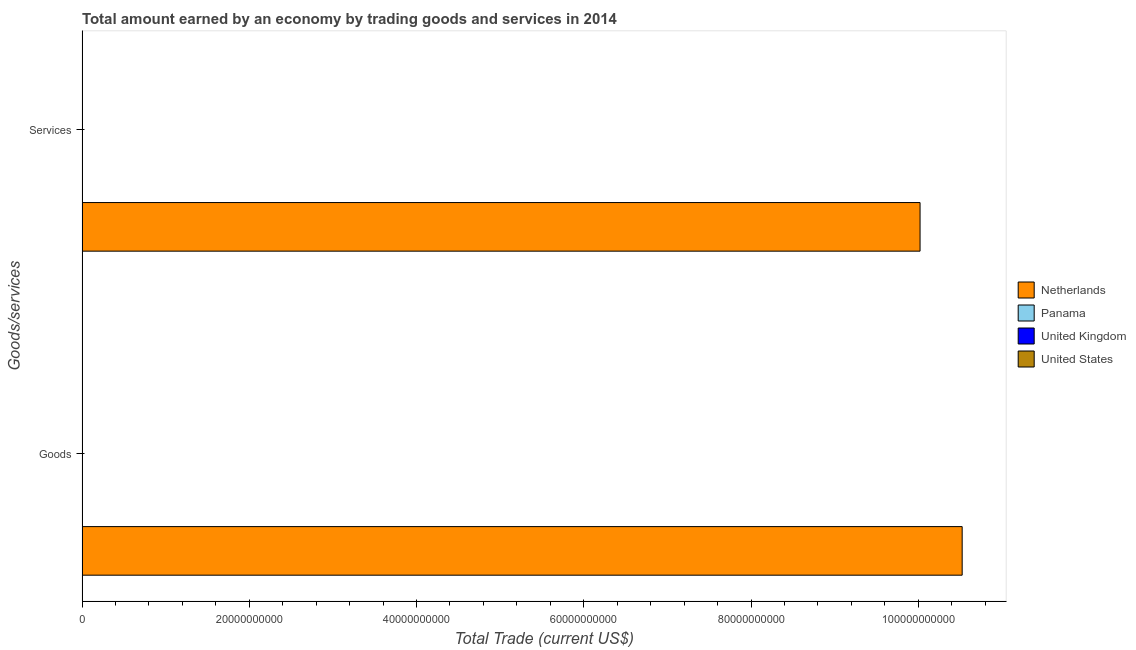How many different coloured bars are there?
Keep it short and to the point. 1. Are the number of bars per tick equal to the number of legend labels?
Give a very brief answer. No. Are the number of bars on each tick of the Y-axis equal?
Offer a very short reply. Yes. How many bars are there on the 1st tick from the top?
Keep it short and to the point. 1. How many bars are there on the 1st tick from the bottom?
Your response must be concise. 1. What is the label of the 2nd group of bars from the top?
Offer a very short reply. Goods. What is the amount earned by trading goods in United States?
Offer a very short reply. 0. Across all countries, what is the maximum amount earned by trading goods?
Keep it short and to the point. 1.05e+11. Across all countries, what is the minimum amount earned by trading services?
Offer a terse response. 0. What is the total amount earned by trading services in the graph?
Keep it short and to the point. 1.00e+11. What is the difference between the amount earned by trading services in United Kingdom and the amount earned by trading goods in Panama?
Give a very brief answer. 0. What is the average amount earned by trading services per country?
Give a very brief answer. 2.51e+1. What is the difference between the amount earned by trading services and amount earned by trading goods in Netherlands?
Give a very brief answer. -5.04e+09. In how many countries, is the amount earned by trading goods greater than 24000000000 US$?
Offer a terse response. 1. In how many countries, is the amount earned by trading services greater than the average amount earned by trading services taken over all countries?
Your answer should be very brief. 1. How many bars are there?
Your response must be concise. 2. How many countries are there in the graph?
Provide a succinct answer. 4. Does the graph contain grids?
Your answer should be very brief. No. How many legend labels are there?
Give a very brief answer. 4. How are the legend labels stacked?
Provide a succinct answer. Vertical. What is the title of the graph?
Make the answer very short. Total amount earned by an economy by trading goods and services in 2014. What is the label or title of the X-axis?
Keep it short and to the point. Total Trade (current US$). What is the label or title of the Y-axis?
Your answer should be compact. Goods/services. What is the Total Trade (current US$) of Netherlands in Goods?
Offer a terse response. 1.05e+11. What is the Total Trade (current US$) in United Kingdom in Goods?
Give a very brief answer. 0. What is the Total Trade (current US$) in United States in Goods?
Your response must be concise. 0. What is the Total Trade (current US$) in Netherlands in Services?
Your response must be concise. 1.00e+11. What is the Total Trade (current US$) in Panama in Services?
Give a very brief answer. 0. Across all Goods/services, what is the maximum Total Trade (current US$) in Netherlands?
Your answer should be very brief. 1.05e+11. Across all Goods/services, what is the minimum Total Trade (current US$) of Netherlands?
Provide a succinct answer. 1.00e+11. What is the total Total Trade (current US$) in Netherlands in the graph?
Your answer should be compact. 2.05e+11. What is the difference between the Total Trade (current US$) in Netherlands in Goods and that in Services?
Give a very brief answer. 5.04e+09. What is the average Total Trade (current US$) of Netherlands per Goods/services?
Your answer should be compact. 1.03e+11. What is the average Total Trade (current US$) of Panama per Goods/services?
Your answer should be very brief. 0. What is the average Total Trade (current US$) of United Kingdom per Goods/services?
Your answer should be very brief. 0. What is the ratio of the Total Trade (current US$) of Netherlands in Goods to that in Services?
Provide a short and direct response. 1.05. What is the difference between the highest and the second highest Total Trade (current US$) of Netherlands?
Offer a very short reply. 5.04e+09. What is the difference between the highest and the lowest Total Trade (current US$) in Netherlands?
Give a very brief answer. 5.04e+09. 